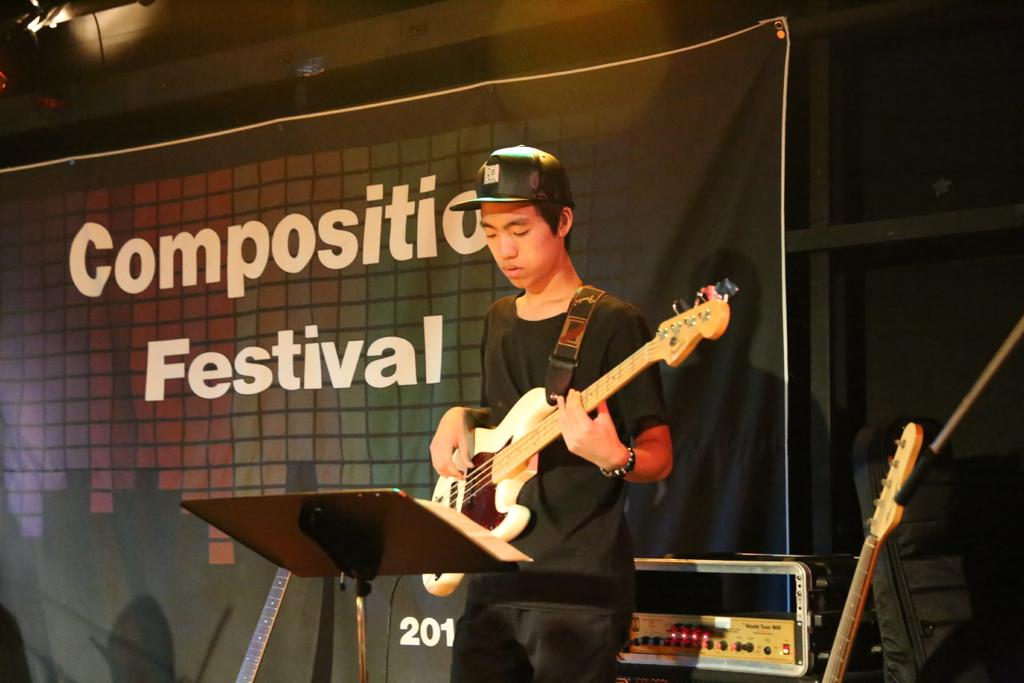What is the person in the image doing? The person is playing a guitar in the image. What object can be seen supporting the guitar? There is a stand in the image to support the guitar. What can be seen on the right side of the image? There is a device on the right side of the image. What is present at the top of the image? There are lights on top in the image. How many snails are crawling on the guitar in the image? There are no snails present in the image; the guitar is being played by a person. 